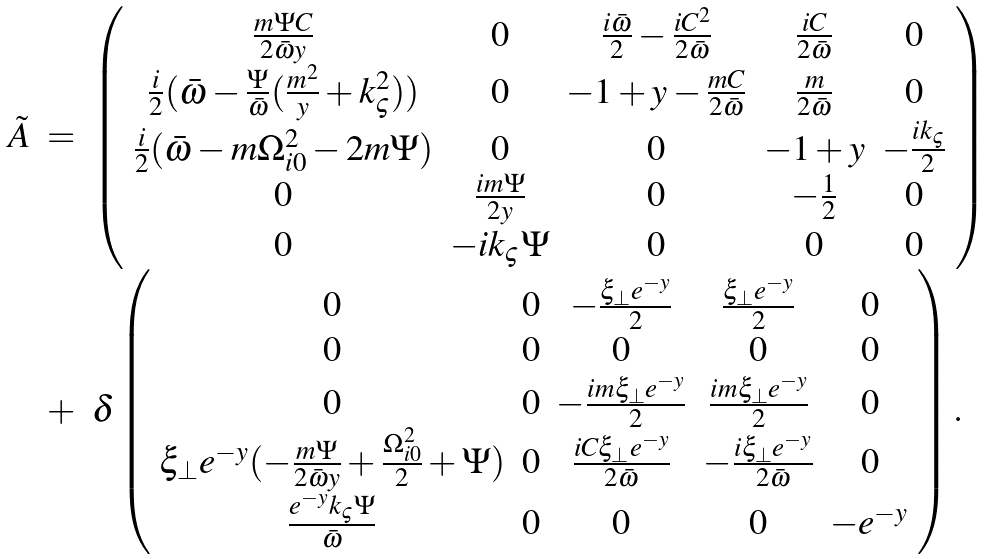<formula> <loc_0><loc_0><loc_500><loc_500>\begin{array} { l l l } \tilde { A } & = & \left ( \begin{array} { c c c c c } \frac { m \Psi C } { 2 \bar { \omega } y } & 0 & \frac { i \bar { \omega } } { 2 } - \frac { i C ^ { 2 } } { 2 \bar { \omega } } & \frac { i C } { 2 \bar { \omega } } & 0 \\ \frac { i } { 2 } ( \bar { \omega } - \frac { \Psi } { \bar { \omega } } ( \frac { m ^ { 2 } } { y } + k _ { \varsigma } ^ { 2 } ) ) & 0 & - 1 + y - \frac { m C } { 2 \bar { \omega } } & \frac { m } { 2 \bar { \omega } } & 0 \\ \frac { i } { 2 } ( \bar { \omega } - m \Omega _ { i 0 } ^ { 2 } - 2 m \Psi ) & 0 & 0 & - 1 + y & - \frac { i k _ { \varsigma } } { 2 } \\ 0 & \frac { i m \Psi } { 2 y } & 0 & - \frac { 1 } { 2 } & 0 \\ 0 & - i k _ { \varsigma } \Psi & 0 & 0 & 0 \\ \end{array} \right ) \\ & + & \delta \left ( \begin{array} { c c c c c } 0 & 0 & - \frac { \xi _ { \bot } e ^ { - y } } { 2 } & \frac { \xi _ { \bot } e ^ { - y } } { 2 } & 0 \\ 0 & 0 & 0 & 0 & 0 \\ 0 & 0 & - \frac { i m \xi _ { \bot } e ^ { - y } } { 2 } & \frac { i m \xi _ { \bot } e ^ { - y } } { 2 } & 0 \\ \xi _ { \bot } e ^ { - y } ( - \frac { m \Psi } { 2 \bar { \omega } y } + \frac { \Omega _ { i 0 } ^ { 2 } } { 2 } + \Psi ) & 0 & \frac { i C \xi _ { \bot } e ^ { - y } } { 2 \bar { \omega } } & - \frac { i \xi _ { \bot } e ^ { - y } } { 2 \bar { \omega } } & 0 \\ \frac { e ^ { - y } k _ { \varsigma } \Psi } { \bar { \omega } } & 0 & 0 & 0 & - e ^ { - y } \end{array} \right ) . \end{array}</formula> 